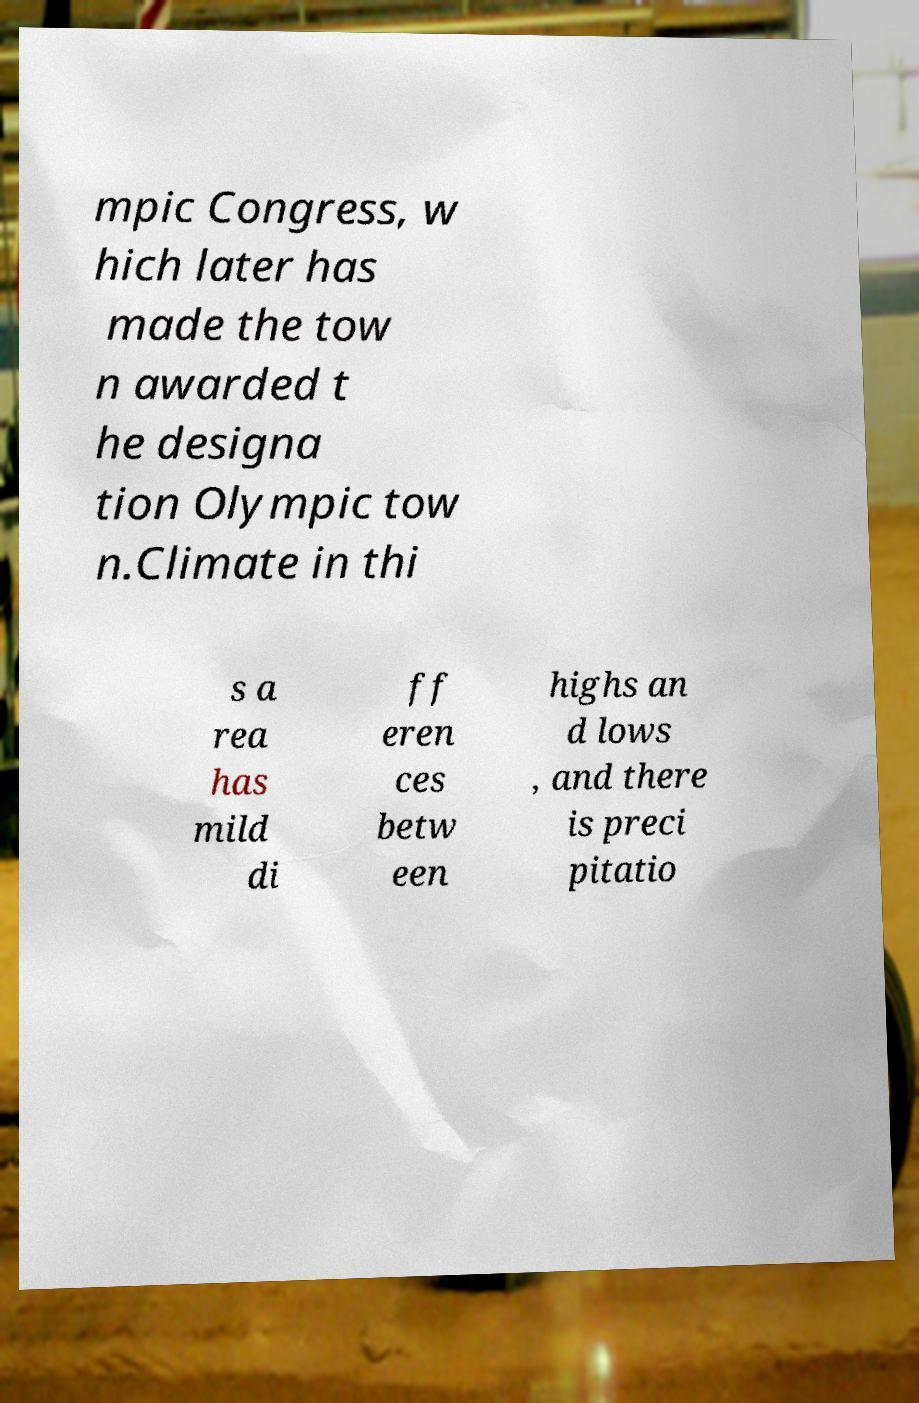Can you accurately transcribe the text from the provided image for me? mpic Congress, w hich later has made the tow n awarded t he designa tion Olympic tow n.Climate in thi s a rea has mild di ff eren ces betw een highs an d lows , and there is preci pitatio 